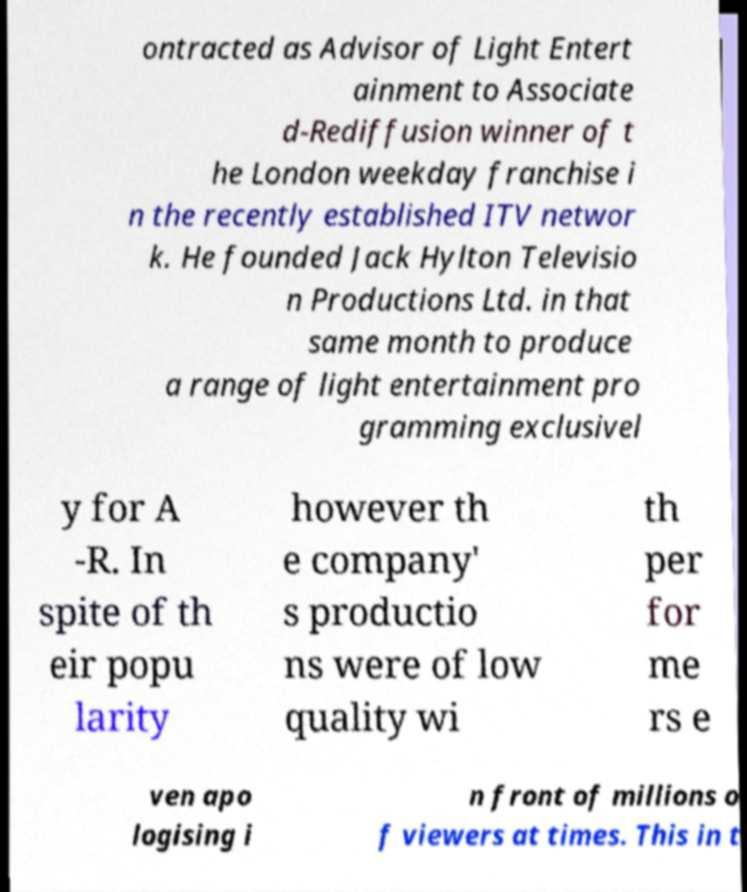There's text embedded in this image that I need extracted. Can you transcribe it verbatim? ontracted as Advisor of Light Entert ainment to Associate d-Rediffusion winner of t he London weekday franchise i n the recently established ITV networ k. He founded Jack Hylton Televisio n Productions Ltd. in that same month to produce a range of light entertainment pro gramming exclusivel y for A -R. In spite of th eir popu larity however th e company' s productio ns were of low quality wi th per for me rs e ven apo logising i n front of millions o f viewers at times. This in t 